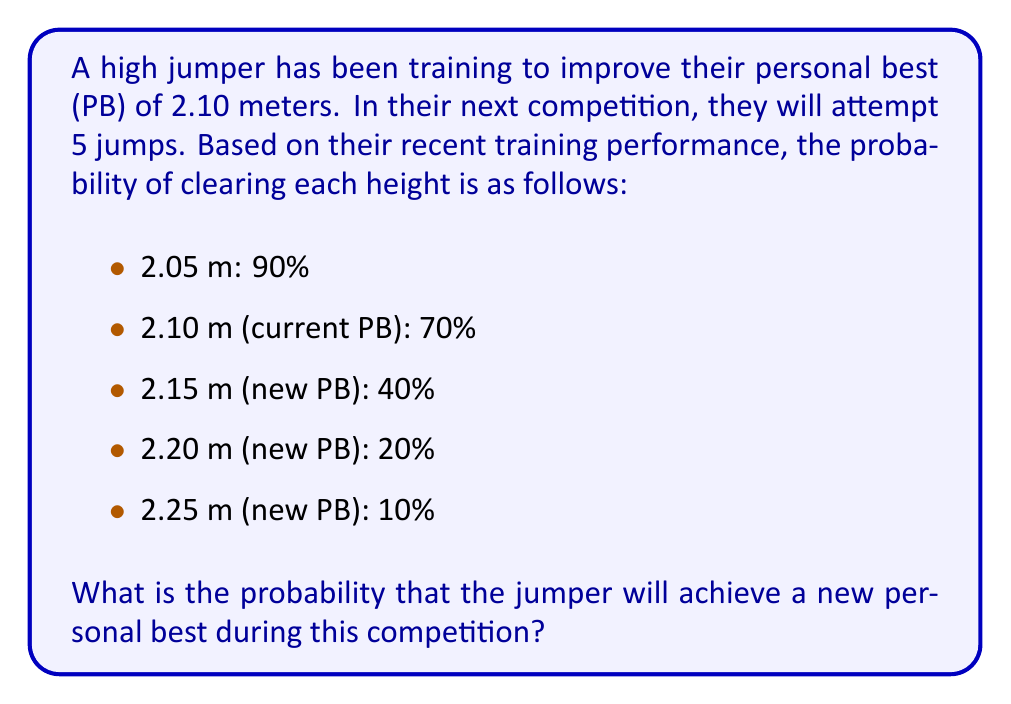Show me your answer to this math problem. Let's approach this step-by-step:

1) First, we need to calculate the probability of not achieving a new PB. This occurs when the jumper fails to clear any height above 2.10 m.

2) The probability of not clearing 2.15 m on a single attempt is 60% (1 - 0.40).

3) For all 5 jumps to be at or below 2.10 m, we need:
   $$(0.60)^5 = 0.07776$$

4) However, this includes the possibility of failing all jumps. We need to subtract the probability of failing all jumps at or below 2.10 m:
   $$(0.10 \times 0.30)^5 = 0.00000243$$

5) So, the probability of not achieving a new PB is:
   $$0.07776 - 0.00000243 = 0.07775757$$

6) Therefore, the probability of achieving a new PB is:
   $$1 - 0.07775757 = 0.92224243$$

This can be interpreted using the principle of conservation of energy in physics. Just as the total energy in a closed system remains constant, the total probability here must sum to 1. The energy required to achieve higher jumps increases, which is analogous to the decreasing probability of success at greater heights.
Answer: $0.92224243$ or approximately $92.22\%$ 